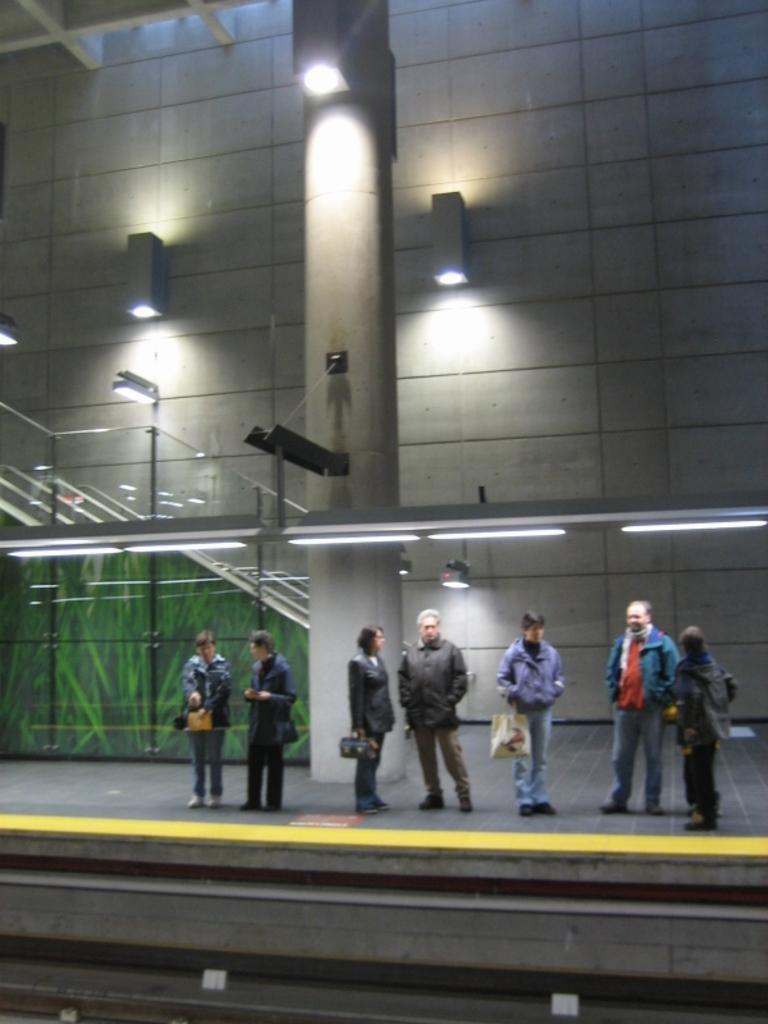How would you summarize this image in a sentence or two? Lights are on the wall and pillar. Here we can see people. These people are holding bags and wore jackets. 